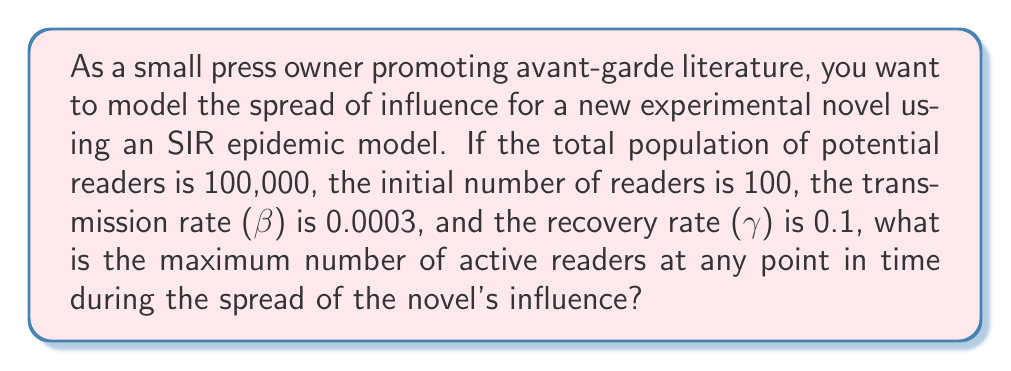Show me your answer to this math problem. To solve this problem, we'll use the SIR (Susceptible, Infected, Recovered) epidemic model to represent the spread of the novel's influence. In this context:

S: Susceptible (potential readers)
I: Infected (active readers)
R: Recovered (those who have finished reading and are no longer actively promoting the book)

The SIR model is described by the following differential equations:

$$\frac{dS}{dt} = -\beta SI$$
$$\frac{dI}{dt} = \beta SI - \gamma I$$
$$\frac{dR}{dt} = \gamma I$$

To find the maximum number of active readers, we need to determine when $\frac{dI}{dt} = 0$:

$$\frac{dI}{dt} = \beta SI - \gamma I = 0$$
$$\beta SI = \gamma I$$
$$S = \frac{\gamma}{\beta}$$

This occurs when the number of susceptible readers equals $\frac{\gamma}{\beta}$.

Given:
- Total population (N) = 100,000
- Initial infected (I₀) = 100
- β = 0.0003
- γ = 0.1

Step 1: Calculate $\frac{\gamma}{\beta}$
$$\frac{\gamma}{\beta} = \frac{0.1}{0.0003} = 333.33$$

Step 2: Calculate the number of recovered readers when $S = \frac{\gamma}{\beta}$
$$R = N - S - I = 100,000 - 333.33 - I$$

Step 3: Use the conservation of population equation
$$N = S + I + R$$
$$100,000 = 333.33 + I + (100,000 - 333.33 - I)$$
$$100,000 = 100,000 + I - I$$

Step 4: Calculate the maximum number of active readers (I)
$$I = 100,000 - 333.33 = 99,666.67$$

Therefore, the maximum number of active readers is approximately 99,667 (rounded to the nearest whole number).
Answer: 99,667 